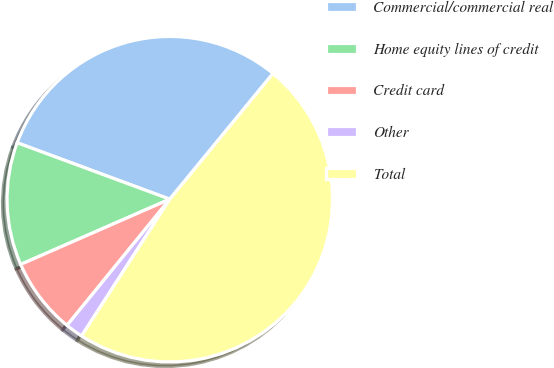Convert chart. <chart><loc_0><loc_0><loc_500><loc_500><pie_chart><fcel>Commercial/commercial real<fcel>Home equity lines of credit<fcel>Credit card<fcel>Other<fcel>Total<nl><fcel>30.3%<fcel>12.2%<fcel>7.56%<fcel>1.76%<fcel>48.17%<nl></chart> 